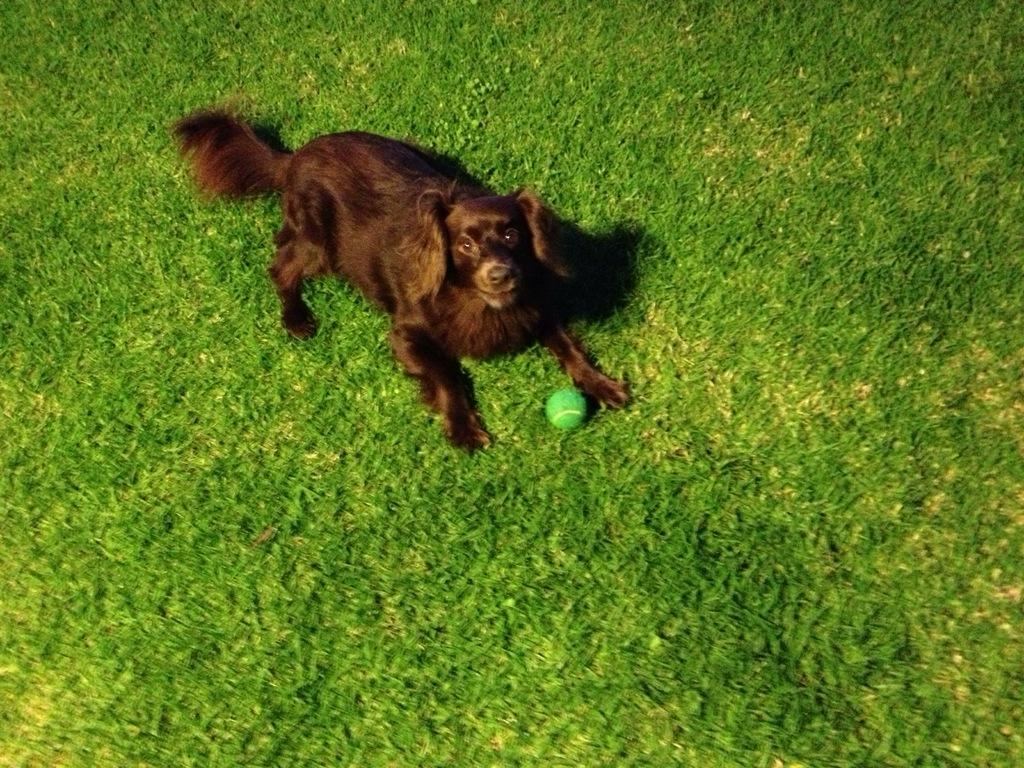What type of animal is present in the image? There is a dog in the image. What object can be seen in the image that is round and green? There is a green color ball in the image. What type of surface is visible in the image? There is grass visible in the image. What type of education does the dog have in the image? There is no indication of the dog's education in the image. What toys can be seen in the image? There are no toys visible in the image; only a dog and a green ball are present. 